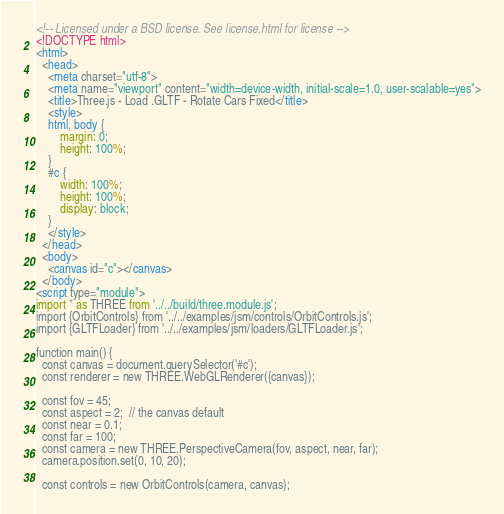<code> <loc_0><loc_0><loc_500><loc_500><_HTML_><!-- Licensed under a BSD license. See license.html for license -->
<!DOCTYPE html>
<html>
  <head>
    <meta charset="utf-8">
    <meta name="viewport" content="width=device-width, initial-scale=1.0, user-scalable=yes">
    <title>Three.js - Load .GLTF - Rotate Cars Fixed</title>
    <style>
    html, body {
        margin: 0;
        height: 100%;
    }
    #c {
        width: 100%;
        height: 100%;
        display: block;
    }
    </style>
  </head>
  <body>
    <canvas id="c"></canvas>
  </body>
<script type="module">
import * as THREE from '../../build/three.module.js';
import {OrbitControls} from '../../examples/jsm/controls/OrbitControls.js';
import {GLTFLoader} from '../../examples/jsm/loaders/GLTFLoader.js';

function main() {
  const canvas = document.querySelector('#c');
  const renderer = new THREE.WebGLRenderer({canvas});

  const fov = 45;
  const aspect = 2;  // the canvas default
  const near = 0.1;
  const far = 100;
  const camera = new THREE.PerspectiveCamera(fov, aspect, near, far);
  camera.position.set(0, 10, 20);

  const controls = new OrbitControls(camera, canvas);</code> 